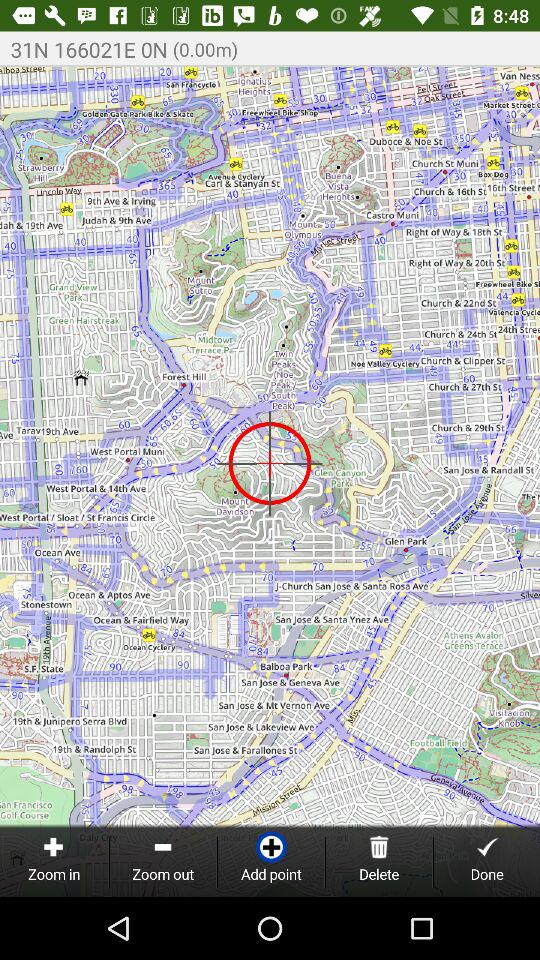How many meters away is the target?
Answer the question using a single word or phrase. 0.00m 